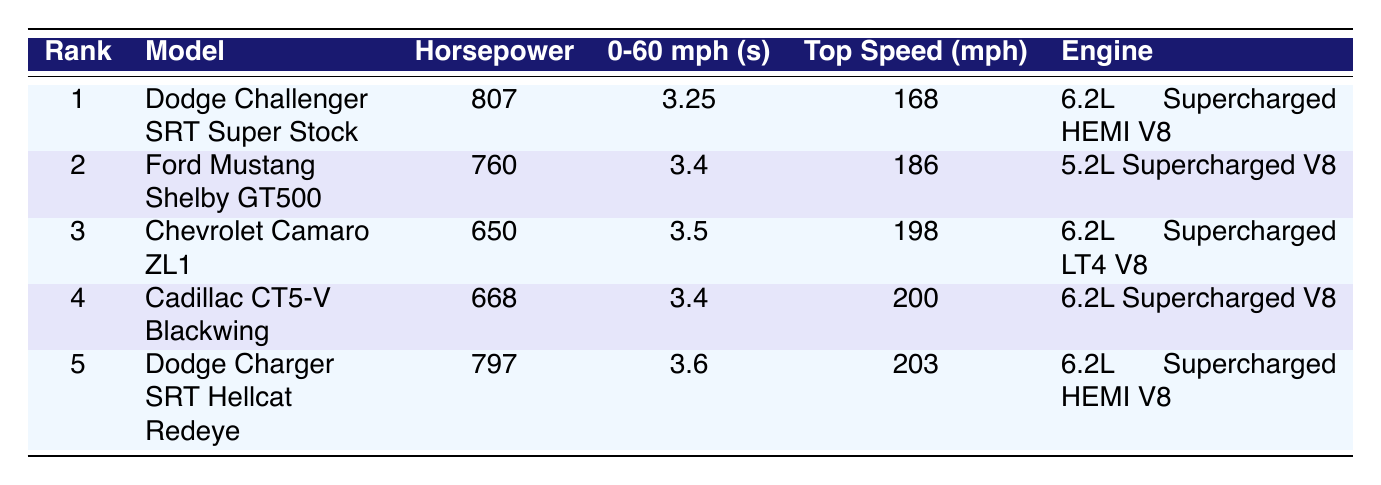What is the horsepower of the Dodge Challenger SRT Super Stock? The row corresponding to the Dodge Challenger SRT Super Stock shows the horsepower value in the third column. The horsepower listed is 807.
Answer: 807 Which car has the highest top speed? The top speed values are found in the fifth column. By comparing the values, the highest top speed is listed for the Dodge Charger SRT Hellcat Redeye with a speed of 203 mph.
Answer: Dodge Charger SRT Hellcat Redeye What is the average horsepower of these top 5 muscle cars? To find the average horsepower, sum the horsepower values: (807 + 760 + 650 + 668 + 797) = 3782. Then, divide by the number of models (5): 3782 / 5 = 756.4.
Answer: 756.4 Is the Ford Mustang Shelby GT500 faster than the Chevrolet Camaro ZL1? The top speeds of both cars can be compared: the Ford Mustang Shelby GT500 has a top speed of 186 mph, while the Chevrolet Camaro ZL1 has a top speed of 198 mph. Since 186 is less than 198, the statement is false.
Answer: No Which engine type is shared by the most muscle car models in the table? The engine types are listed in the last column. By observing the list, "6.2L Supercharged V8" and "6.2L Supercharged HEMI V8" both appear several times. The "6.2L Supercharged HEMI V8" is found in the Dodge Challenger SRT Super Stock and Dodge Charger SRT Hellcat Redeye (2 models), while "6.2L Supercharged V8" is found in the Cadillac CT5-V Blackwing and Chevrolet Camaro ZL1 (2 models). Thus, both types are shared equally among 2 models.
Answer: 6.2L Supercharged V8 and 6.2L Supercharged HEMI V8 (both shared by 2 models) How many seconds does it take for the Cadillac CT5-V Blackwing to go from 0-60 mph? The row for the Cadillac CT5-V Blackwing shows the 0-60 mph time in the fourth column, which indicates that it takes 3.4 seconds.
Answer: 3.4 seconds 